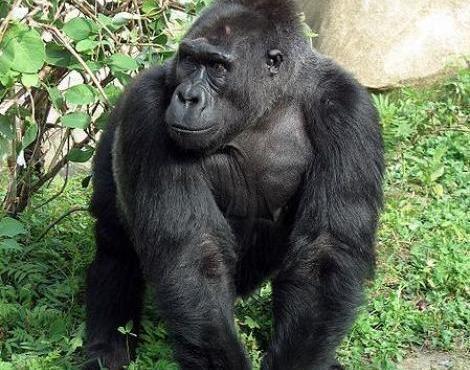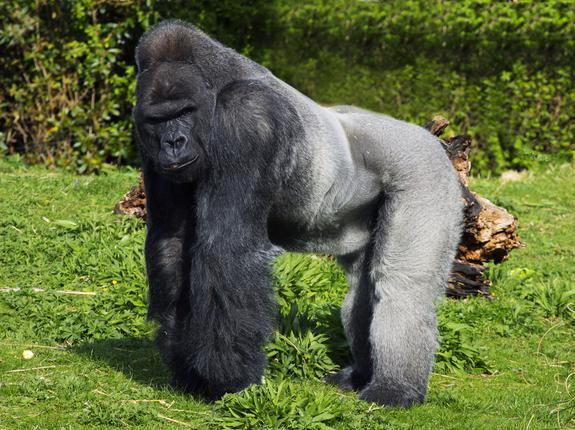The first image is the image on the left, the second image is the image on the right. Examine the images to the left and right. Is the description "All gorillas are standing on all fours, and no image contains more than one gorilla." accurate? Answer yes or no. Yes. The first image is the image on the left, the second image is the image on the right. For the images displayed, is the sentence "A single primate is hunched over on all fours in the grass in each image." factually correct? Answer yes or no. Yes. 